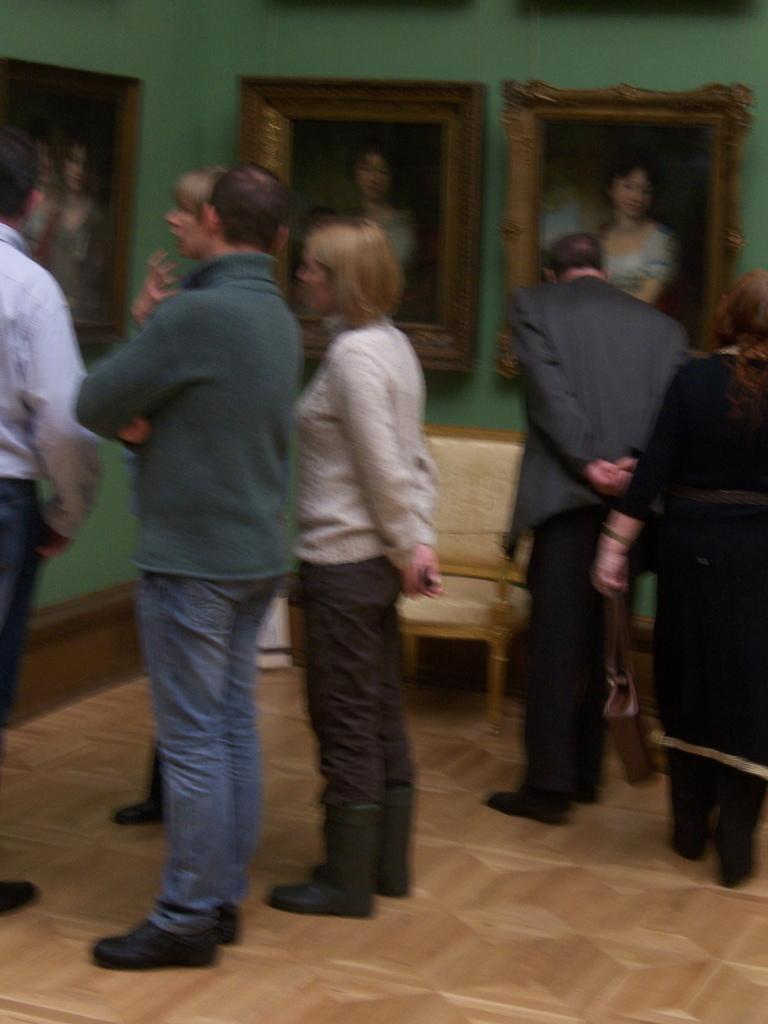What is the setting of the image? The setting of the image is inside a house. What furniture can be seen in the house? There is a chair in the house. Are there any decorations on the wall? Yes, there are photo frames attached to the wall. What color is the wall in the image? The wall is green in color. What type of field can be seen in the image? There is no field present in the image; it is set inside a house. What season is depicted in the image? The provided facts do not mention any seasonal details, so it cannot be determined from the image. 